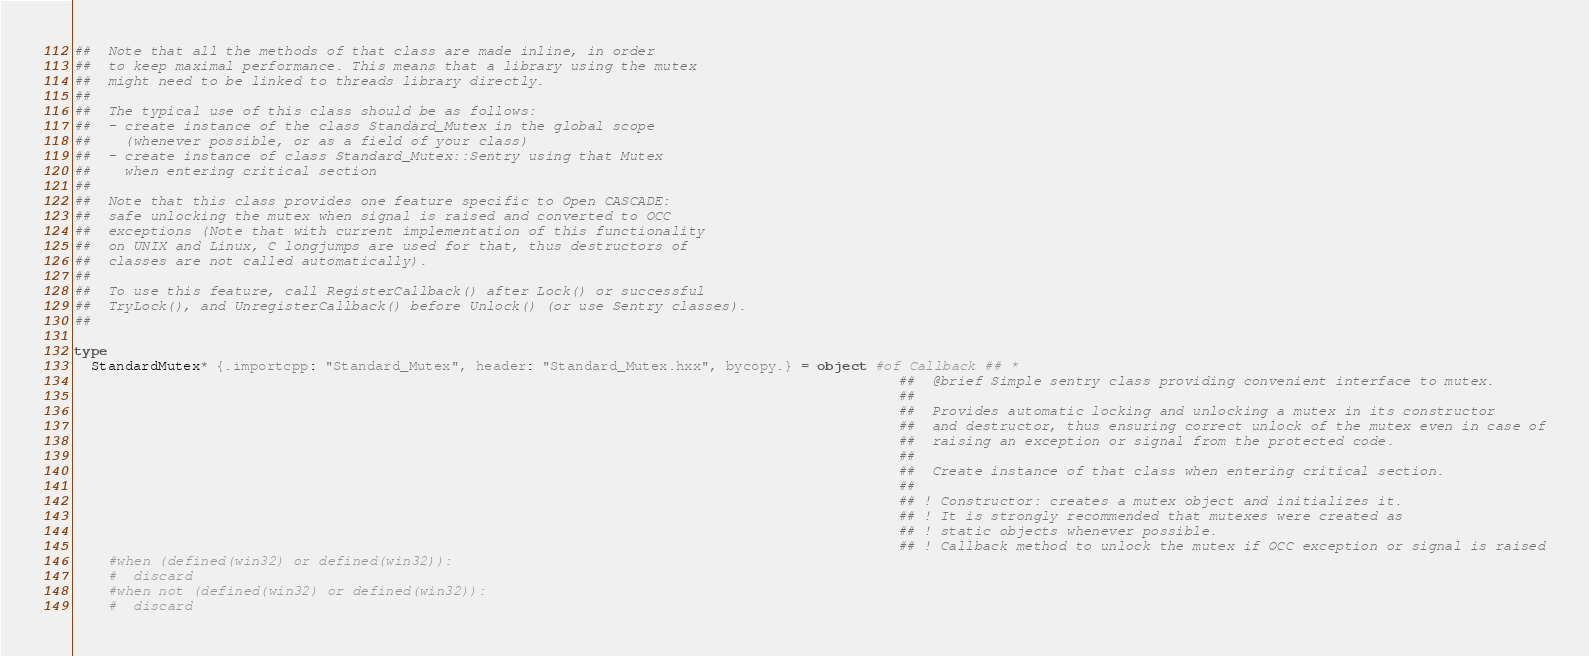Convert code to text. <code><loc_0><loc_0><loc_500><loc_500><_Nim_>##  Note that all the methods of that class are made inline, in order
##  to keep maximal performance. This means that a library using the mutex
##  might need to be linked to threads library directly.
##
##  The typical use of this class should be as follows:
##  - create instance of the class Standard_Mutex in the global scope
##    (whenever possible, or as a field of your class)
##  - create instance of class Standard_Mutex::Sentry using that Mutex
##    when entering critical section
##
##  Note that this class provides one feature specific to Open CASCADE:
##  safe unlocking the mutex when signal is raised and converted to OCC
##  exceptions (Note that with current implementation of this functionality
##  on UNIX and Linux, C longjumps are used for that, thus destructors of
##  classes are not called automatically).
##
##  To use this feature, call RegisterCallback() after Lock() or successful
##  TryLock(), and UnregisterCallback() before Unlock() (or use Sentry classes).
##

type
  StandardMutex* {.importcpp: "Standard_Mutex", header: "Standard_Mutex.hxx", bycopy.} = object #of Callback ## *
                                                                                                  ##  @brief Simple sentry class providing convenient interface to mutex.
                                                                                                  ##
                                                                                                  ##  Provides automatic locking and unlocking a mutex in its constructor
                                                                                                  ##  and destructor, thus ensuring correct unlock of the mutex even in case of
                                                                                                  ##  raising an exception or signal from the protected code.
                                                                                                  ##
                                                                                                  ##  Create instance of that class when entering critical section.
                                                                                                  ##
                                                                                                  ## ! Constructor: creates a mutex object and initializes it.
                                                                                                  ## ! It is strongly recommended that mutexes were created as
                                                                                                  ## ! static objects whenever possible.
                                                                                                  ## ! Callback method to unlock the mutex if OCC exception or signal is raised
    #when (defined(win32) or defined(win32)):
    #  discard
    #when not (defined(win32) or defined(win32)):
    #  discard
</code> 